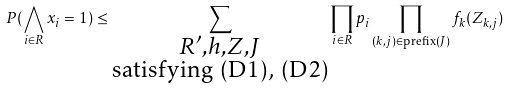Convert formula to latex. <formula><loc_0><loc_0><loc_500><loc_500>P ( \bigwedge _ { i \in R } x _ { i } = 1 ) \leq \sum _ { \substack { R ^ { \prime } , h , Z , J \\ \text {satisfying (D1), (D2)} } } \prod _ { i \in R } p _ { i } \prod _ { ( k , j ) \in \text {prefix} ( J ) } f _ { k } ( Z _ { k , j } )</formula> 